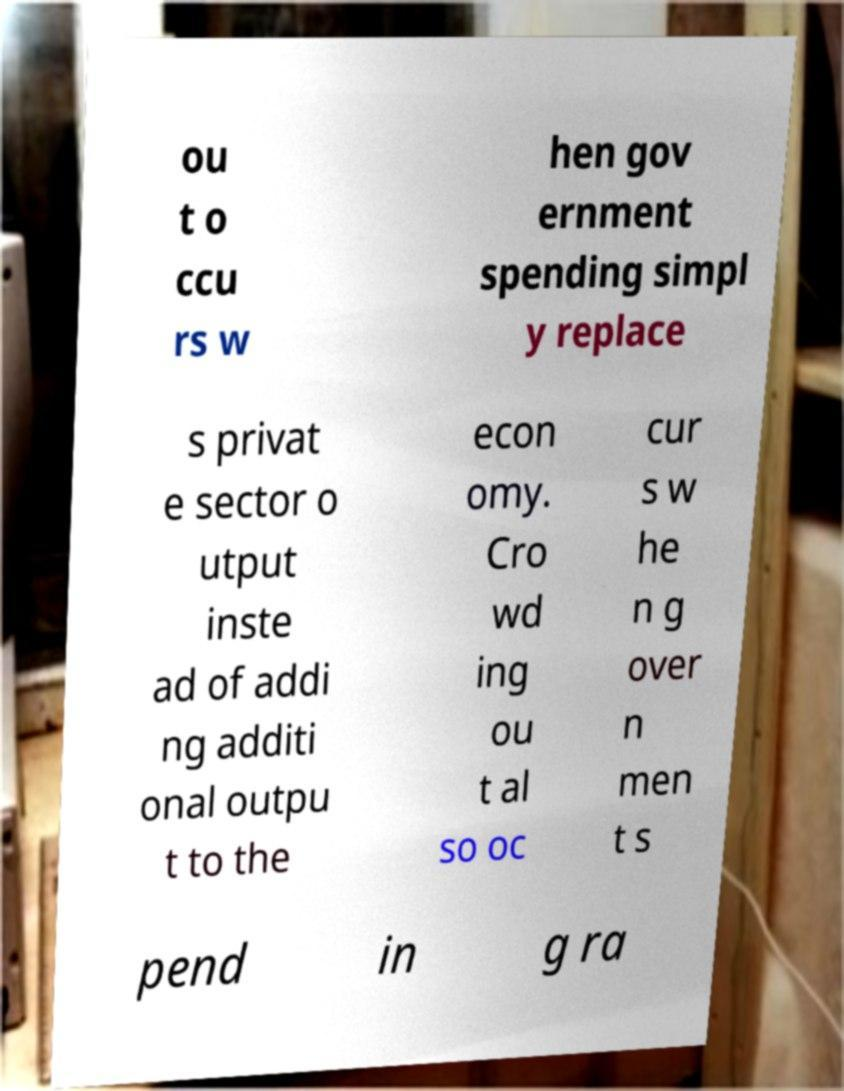There's text embedded in this image that I need extracted. Can you transcribe it verbatim? ou t o ccu rs w hen gov ernment spending simpl y replace s privat e sector o utput inste ad of addi ng additi onal outpu t to the econ omy. Cro wd ing ou t al so oc cur s w he n g over n men t s pend in g ra 